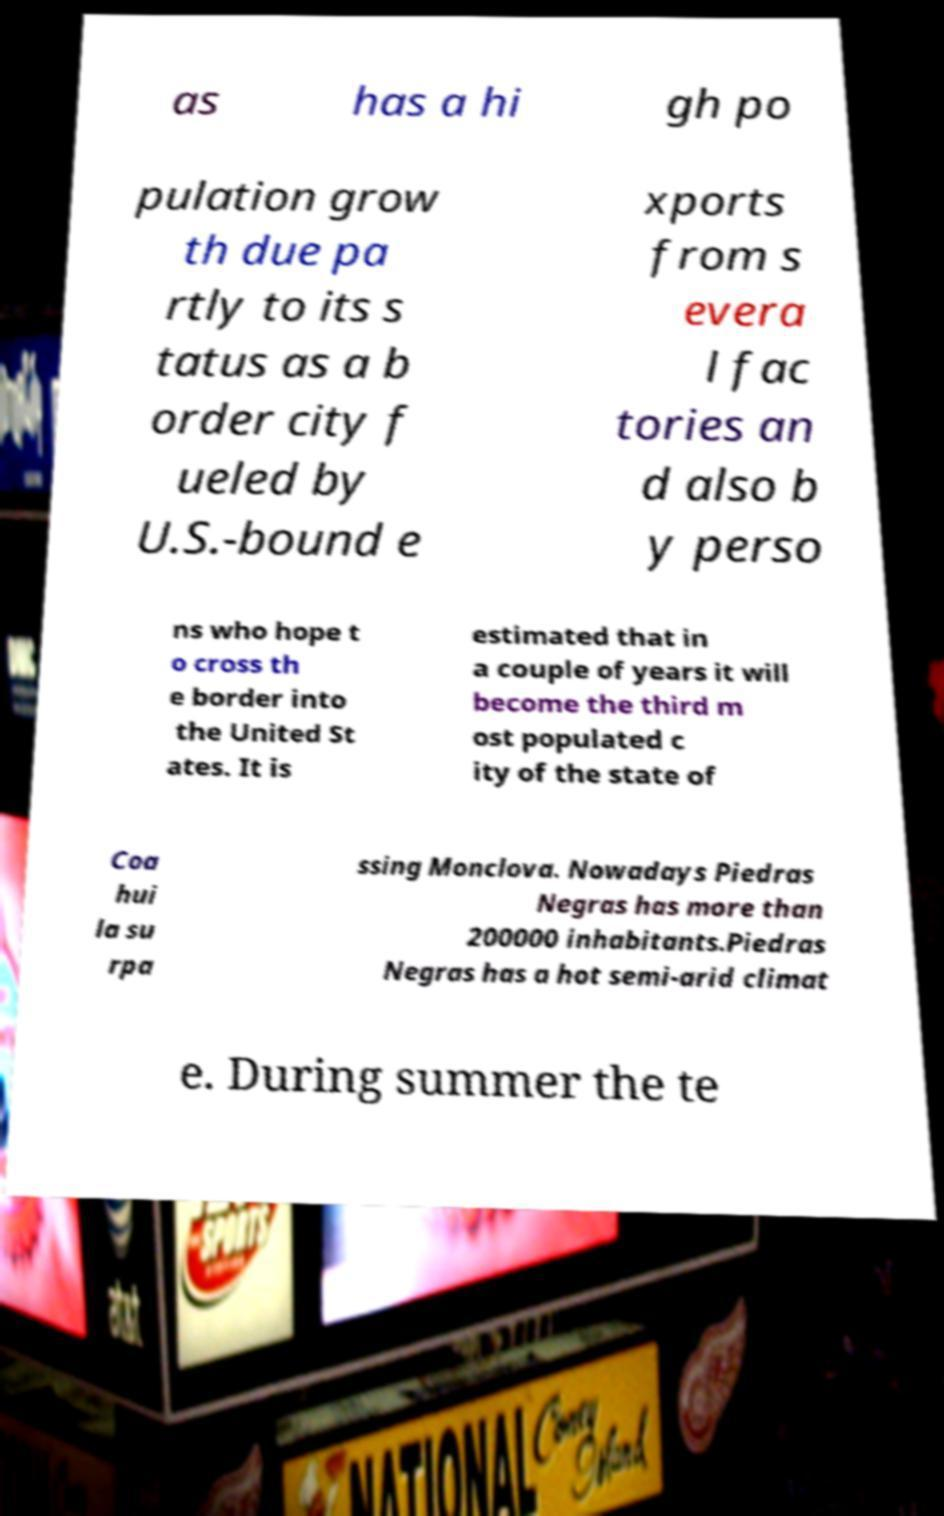For documentation purposes, I need the text within this image transcribed. Could you provide that? as has a hi gh po pulation grow th due pa rtly to its s tatus as a b order city f ueled by U.S.-bound e xports from s evera l fac tories an d also b y perso ns who hope t o cross th e border into the United St ates. It is estimated that in a couple of years it will become the third m ost populated c ity of the state of Coa hui la su rpa ssing Monclova. Nowadays Piedras Negras has more than 200000 inhabitants.Piedras Negras has a hot semi-arid climat e. During summer the te 